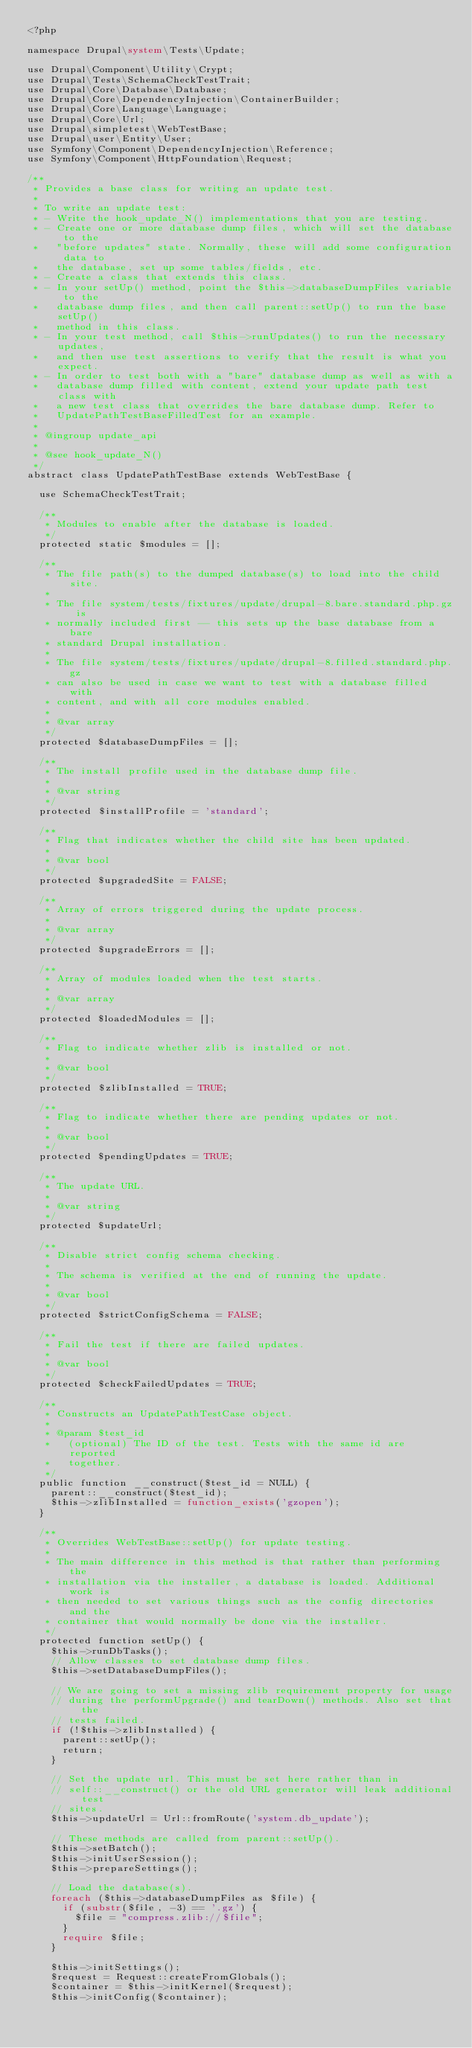Convert code to text. <code><loc_0><loc_0><loc_500><loc_500><_PHP_><?php

namespace Drupal\system\Tests\Update;

use Drupal\Component\Utility\Crypt;
use Drupal\Tests\SchemaCheckTestTrait;
use Drupal\Core\Database\Database;
use Drupal\Core\DependencyInjection\ContainerBuilder;
use Drupal\Core\Language\Language;
use Drupal\Core\Url;
use Drupal\simpletest\WebTestBase;
use Drupal\user\Entity\User;
use Symfony\Component\DependencyInjection\Reference;
use Symfony\Component\HttpFoundation\Request;

/**
 * Provides a base class for writing an update test.
 *
 * To write an update test:
 * - Write the hook_update_N() implementations that you are testing.
 * - Create one or more database dump files, which will set the database to the
 *   "before updates" state. Normally, these will add some configuration data to
 *   the database, set up some tables/fields, etc.
 * - Create a class that extends this class.
 * - In your setUp() method, point the $this->databaseDumpFiles variable to the
 *   database dump files, and then call parent::setUp() to run the base setUp()
 *   method in this class.
 * - In your test method, call $this->runUpdates() to run the necessary updates,
 *   and then use test assertions to verify that the result is what you expect.
 * - In order to test both with a "bare" database dump as well as with a
 *   database dump filled with content, extend your update path test class with
 *   a new test class that overrides the bare database dump. Refer to
 *   UpdatePathTestBaseFilledTest for an example.
 *
 * @ingroup update_api
 *
 * @see hook_update_N()
 */
abstract class UpdatePathTestBase extends WebTestBase {

  use SchemaCheckTestTrait;

  /**
   * Modules to enable after the database is loaded.
   */
  protected static $modules = [];

  /**
   * The file path(s) to the dumped database(s) to load into the child site.
   *
   * The file system/tests/fixtures/update/drupal-8.bare.standard.php.gz is
   * normally included first -- this sets up the base database from a bare
   * standard Drupal installation.
   *
   * The file system/tests/fixtures/update/drupal-8.filled.standard.php.gz
   * can also be used in case we want to test with a database filled with
   * content, and with all core modules enabled.
   *
   * @var array
   */
  protected $databaseDumpFiles = [];

  /**
   * The install profile used in the database dump file.
   *
   * @var string
   */
  protected $installProfile = 'standard';

  /**
   * Flag that indicates whether the child site has been updated.
   *
   * @var bool
   */
  protected $upgradedSite = FALSE;

  /**
   * Array of errors triggered during the update process.
   *
   * @var array
   */
  protected $upgradeErrors = [];

  /**
   * Array of modules loaded when the test starts.
   *
   * @var array
   */
  protected $loadedModules = [];

  /**
   * Flag to indicate whether zlib is installed or not.
   *
   * @var bool
   */
  protected $zlibInstalled = TRUE;

  /**
   * Flag to indicate whether there are pending updates or not.
   *
   * @var bool
   */
  protected $pendingUpdates = TRUE;

  /**
   * The update URL.
   *
   * @var string
   */
  protected $updateUrl;

  /**
   * Disable strict config schema checking.
   *
   * The schema is verified at the end of running the update.
   *
   * @var bool
   */
  protected $strictConfigSchema = FALSE;

  /**
   * Fail the test if there are failed updates.
   *
   * @var bool
   */
  protected $checkFailedUpdates = TRUE;

  /**
   * Constructs an UpdatePathTestCase object.
   *
   * @param $test_id
   *   (optional) The ID of the test. Tests with the same id are reported
   *   together.
   */
  public function __construct($test_id = NULL) {
    parent::__construct($test_id);
    $this->zlibInstalled = function_exists('gzopen');
  }

  /**
   * Overrides WebTestBase::setUp() for update testing.
   *
   * The main difference in this method is that rather than performing the
   * installation via the installer, a database is loaded. Additional work is
   * then needed to set various things such as the config directories and the
   * container that would normally be done via the installer.
   */
  protected function setUp() {
    $this->runDbTasks();
    // Allow classes to set database dump files.
    $this->setDatabaseDumpFiles();

    // We are going to set a missing zlib requirement property for usage
    // during the performUpgrade() and tearDown() methods. Also set that the
    // tests failed.
    if (!$this->zlibInstalled) {
      parent::setUp();
      return;
    }

    // Set the update url. This must be set here rather than in
    // self::__construct() or the old URL generator will leak additional test
    // sites.
    $this->updateUrl = Url::fromRoute('system.db_update');

    // These methods are called from parent::setUp().
    $this->setBatch();
    $this->initUserSession();
    $this->prepareSettings();

    // Load the database(s).
    foreach ($this->databaseDumpFiles as $file) {
      if (substr($file, -3) == '.gz') {
        $file = "compress.zlib://$file";
      }
      require $file;
    }

    $this->initSettings();
    $request = Request::createFromGlobals();
    $container = $this->initKernel($request);
    $this->initConfig($container);
</code> 